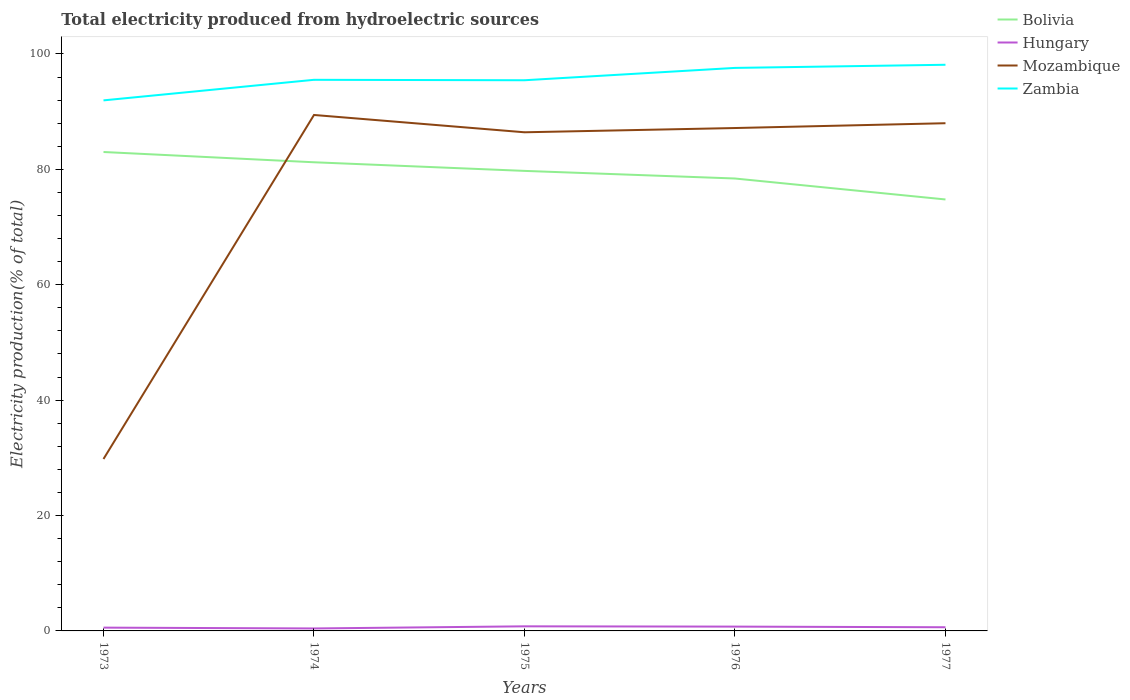How many different coloured lines are there?
Your answer should be compact. 4. Is the number of lines equal to the number of legend labels?
Keep it short and to the point. Yes. Across all years, what is the maximum total electricity produced in Hungary?
Give a very brief answer. 0.43. In which year was the total electricity produced in Bolivia maximum?
Keep it short and to the point. 1977. What is the total total electricity produced in Hungary in the graph?
Keep it short and to the point. 0.15. What is the difference between the highest and the second highest total electricity produced in Mozambique?
Ensure brevity in your answer.  59.63. How many lines are there?
Give a very brief answer. 4. How many years are there in the graph?
Your answer should be compact. 5. Are the values on the major ticks of Y-axis written in scientific E-notation?
Provide a succinct answer. No. Does the graph contain any zero values?
Offer a terse response. No. Does the graph contain grids?
Offer a very short reply. No. Where does the legend appear in the graph?
Ensure brevity in your answer.  Top right. How many legend labels are there?
Provide a succinct answer. 4. What is the title of the graph?
Your response must be concise. Total electricity produced from hydroelectric sources. What is the label or title of the X-axis?
Make the answer very short. Years. What is the label or title of the Y-axis?
Your response must be concise. Electricity production(% of total). What is the Electricity production(% of total) of Bolivia in 1973?
Provide a short and direct response. 83.01. What is the Electricity production(% of total) of Hungary in 1973?
Offer a very short reply. 0.57. What is the Electricity production(% of total) in Mozambique in 1973?
Provide a succinct answer. 29.8. What is the Electricity production(% of total) of Zambia in 1973?
Your answer should be compact. 91.95. What is the Electricity production(% of total) in Bolivia in 1974?
Your response must be concise. 81.23. What is the Electricity production(% of total) in Hungary in 1974?
Offer a terse response. 0.43. What is the Electricity production(% of total) in Mozambique in 1974?
Ensure brevity in your answer.  89.42. What is the Electricity production(% of total) of Zambia in 1974?
Offer a very short reply. 95.52. What is the Electricity production(% of total) in Bolivia in 1975?
Make the answer very short. 79.73. What is the Electricity production(% of total) in Hungary in 1975?
Ensure brevity in your answer.  0.8. What is the Electricity production(% of total) in Mozambique in 1975?
Make the answer very short. 86.42. What is the Electricity production(% of total) of Zambia in 1975?
Give a very brief answer. 95.44. What is the Electricity production(% of total) of Bolivia in 1976?
Provide a succinct answer. 78.41. What is the Electricity production(% of total) of Hungary in 1976?
Offer a very short reply. 0.75. What is the Electricity production(% of total) in Mozambique in 1976?
Keep it short and to the point. 87.16. What is the Electricity production(% of total) in Zambia in 1976?
Your response must be concise. 97.58. What is the Electricity production(% of total) of Bolivia in 1977?
Your answer should be compact. 74.78. What is the Electricity production(% of total) of Hungary in 1977?
Provide a succinct answer. 0.64. What is the Electricity production(% of total) in Mozambique in 1977?
Keep it short and to the point. 87.99. What is the Electricity production(% of total) of Zambia in 1977?
Offer a terse response. 98.13. Across all years, what is the maximum Electricity production(% of total) of Bolivia?
Keep it short and to the point. 83.01. Across all years, what is the maximum Electricity production(% of total) of Hungary?
Provide a succinct answer. 0.8. Across all years, what is the maximum Electricity production(% of total) in Mozambique?
Ensure brevity in your answer.  89.42. Across all years, what is the maximum Electricity production(% of total) of Zambia?
Your answer should be very brief. 98.13. Across all years, what is the minimum Electricity production(% of total) in Bolivia?
Your answer should be very brief. 74.78. Across all years, what is the minimum Electricity production(% of total) in Hungary?
Give a very brief answer. 0.43. Across all years, what is the minimum Electricity production(% of total) in Mozambique?
Your response must be concise. 29.8. Across all years, what is the minimum Electricity production(% of total) of Zambia?
Your response must be concise. 91.95. What is the total Electricity production(% of total) of Bolivia in the graph?
Provide a short and direct response. 397.16. What is the total Electricity production(% of total) in Hungary in the graph?
Keep it short and to the point. 3.18. What is the total Electricity production(% of total) of Mozambique in the graph?
Offer a terse response. 380.8. What is the total Electricity production(% of total) of Zambia in the graph?
Offer a terse response. 478.62. What is the difference between the Electricity production(% of total) of Bolivia in 1973 and that in 1974?
Your answer should be compact. 1.78. What is the difference between the Electricity production(% of total) in Hungary in 1973 and that in 1974?
Your answer should be very brief. 0.15. What is the difference between the Electricity production(% of total) of Mozambique in 1973 and that in 1974?
Give a very brief answer. -59.63. What is the difference between the Electricity production(% of total) of Zambia in 1973 and that in 1974?
Provide a succinct answer. -3.56. What is the difference between the Electricity production(% of total) of Bolivia in 1973 and that in 1975?
Keep it short and to the point. 3.27. What is the difference between the Electricity production(% of total) of Hungary in 1973 and that in 1975?
Ensure brevity in your answer.  -0.22. What is the difference between the Electricity production(% of total) of Mozambique in 1973 and that in 1975?
Make the answer very short. -56.63. What is the difference between the Electricity production(% of total) of Zambia in 1973 and that in 1975?
Ensure brevity in your answer.  -3.49. What is the difference between the Electricity production(% of total) of Bolivia in 1973 and that in 1976?
Offer a terse response. 4.59. What is the difference between the Electricity production(% of total) of Hungary in 1973 and that in 1976?
Your answer should be very brief. -0.18. What is the difference between the Electricity production(% of total) in Mozambique in 1973 and that in 1976?
Provide a succinct answer. -57.36. What is the difference between the Electricity production(% of total) of Zambia in 1973 and that in 1976?
Your answer should be compact. -5.63. What is the difference between the Electricity production(% of total) in Bolivia in 1973 and that in 1977?
Make the answer very short. 8.23. What is the difference between the Electricity production(% of total) of Hungary in 1973 and that in 1977?
Your response must be concise. -0.06. What is the difference between the Electricity production(% of total) of Mozambique in 1973 and that in 1977?
Ensure brevity in your answer.  -58.2. What is the difference between the Electricity production(% of total) of Zambia in 1973 and that in 1977?
Offer a terse response. -6.17. What is the difference between the Electricity production(% of total) in Bolivia in 1974 and that in 1975?
Ensure brevity in your answer.  1.49. What is the difference between the Electricity production(% of total) in Hungary in 1974 and that in 1975?
Your answer should be compact. -0.37. What is the difference between the Electricity production(% of total) in Mozambique in 1974 and that in 1975?
Offer a terse response. 3. What is the difference between the Electricity production(% of total) in Zambia in 1974 and that in 1975?
Ensure brevity in your answer.  0.08. What is the difference between the Electricity production(% of total) in Bolivia in 1974 and that in 1976?
Ensure brevity in your answer.  2.81. What is the difference between the Electricity production(% of total) in Hungary in 1974 and that in 1976?
Give a very brief answer. -0.32. What is the difference between the Electricity production(% of total) in Mozambique in 1974 and that in 1976?
Keep it short and to the point. 2.26. What is the difference between the Electricity production(% of total) in Zambia in 1974 and that in 1976?
Your answer should be very brief. -2.06. What is the difference between the Electricity production(% of total) in Bolivia in 1974 and that in 1977?
Offer a terse response. 6.45. What is the difference between the Electricity production(% of total) in Hungary in 1974 and that in 1977?
Ensure brevity in your answer.  -0.21. What is the difference between the Electricity production(% of total) of Mozambique in 1974 and that in 1977?
Keep it short and to the point. 1.43. What is the difference between the Electricity production(% of total) in Zambia in 1974 and that in 1977?
Offer a very short reply. -2.61. What is the difference between the Electricity production(% of total) of Bolivia in 1975 and that in 1976?
Make the answer very short. 1.32. What is the difference between the Electricity production(% of total) of Hungary in 1975 and that in 1976?
Your response must be concise. 0.05. What is the difference between the Electricity production(% of total) of Mozambique in 1975 and that in 1976?
Provide a short and direct response. -0.74. What is the difference between the Electricity production(% of total) in Zambia in 1975 and that in 1976?
Give a very brief answer. -2.14. What is the difference between the Electricity production(% of total) in Bolivia in 1975 and that in 1977?
Give a very brief answer. 4.95. What is the difference between the Electricity production(% of total) in Hungary in 1975 and that in 1977?
Make the answer very short. 0.16. What is the difference between the Electricity production(% of total) of Mozambique in 1975 and that in 1977?
Your answer should be very brief. -1.57. What is the difference between the Electricity production(% of total) in Zambia in 1975 and that in 1977?
Your answer should be compact. -2.68. What is the difference between the Electricity production(% of total) of Bolivia in 1976 and that in 1977?
Offer a terse response. 3.63. What is the difference between the Electricity production(% of total) of Hungary in 1976 and that in 1977?
Make the answer very short. 0.11. What is the difference between the Electricity production(% of total) in Mozambique in 1976 and that in 1977?
Keep it short and to the point. -0.83. What is the difference between the Electricity production(% of total) of Zambia in 1976 and that in 1977?
Offer a very short reply. -0.55. What is the difference between the Electricity production(% of total) in Bolivia in 1973 and the Electricity production(% of total) in Hungary in 1974?
Your answer should be compact. 82.58. What is the difference between the Electricity production(% of total) in Bolivia in 1973 and the Electricity production(% of total) in Mozambique in 1974?
Provide a succinct answer. -6.42. What is the difference between the Electricity production(% of total) of Bolivia in 1973 and the Electricity production(% of total) of Zambia in 1974?
Offer a very short reply. -12.51. What is the difference between the Electricity production(% of total) in Hungary in 1973 and the Electricity production(% of total) in Mozambique in 1974?
Your answer should be very brief. -88.85. What is the difference between the Electricity production(% of total) in Hungary in 1973 and the Electricity production(% of total) in Zambia in 1974?
Your answer should be very brief. -94.95. What is the difference between the Electricity production(% of total) in Mozambique in 1973 and the Electricity production(% of total) in Zambia in 1974?
Your response must be concise. -65.72. What is the difference between the Electricity production(% of total) in Bolivia in 1973 and the Electricity production(% of total) in Hungary in 1975?
Offer a very short reply. 82.21. What is the difference between the Electricity production(% of total) in Bolivia in 1973 and the Electricity production(% of total) in Mozambique in 1975?
Keep it short and to the point. -3.42. What is the difference between the Electricity production(% of total) of Bolivia in 1973 and the Electricity production(% of total) of Zambia in 1975?
Keep it short and to the point. -12.44. What is the difference between the Electricity production(% of total) in Hungary in 1973 and the Electricity production(% of total) in Mozambique in 1975?
Make the answer very short. -85.85. What is the difference between the Electricity production(% of total) in Hungary in 1973 and the Electricity production(% of total) in Zambia in 1975?
Offer a terse response. -94.87. What is the difference between the Electricity production(% of total) of Mozambique in 1973 and the Electricity production(% of total) of Zambia in 1975?
Provide a short and direct response. -65.64. What is the difference between the Electricity production(% of total) of Bolivia in 1973 and the Electricity production(% of total) of Hungary in 1976?
Your answer should be compact. 82.26. What is the difference between the Electricity production(% of total) in Bolivia in 1973 and the Electricity production(% of total) in Mozambique in 1976?
Make the answer very short. -4.16. What is the difference between the Electricity production(% of total) of Bolivia in 1973 and the Electricity production(% of total) of Zambia in 1976?
Give a very brief answer. -14.57. What is the difference between the Electricity production(% of total) in Hungary in 1973 and the Electricity production(% of total) in Mozambique in 1976?
Offer a very short reply. -86.59. What is the difference between the Electricity production(% of total) of Hungary in 1973 and the Electricity production(% of total) of Zambia in 1976?
Offer a very short reply. -97.01. What is the difference between the Electricity production(% of total) in Mozambique in 1973 and the Electricity production(% of total) in Zambia in 1976?
Offer a terse response. -67.78. What is the difference between the Electricity production(% of total) of Bolivia in 1973 and the Electricity production(% of total) of Hungary in 1977?
Your answer should be compact. 82.37. What is the difference between the Electricity production(% of total) of Bolivia in 1973 and the Electricity production(% of total) of Mozambique in 1977?
Keep it short and to the point. -4.99. What is the difference between the Electricity production(% of total) in Bolivia in 1973 and the Electricity production(% of total) in Zambia in 1977?
Offer a terse response. -15.12. What is the difference between the Electricity production(% of total) in Hungary in 1973 and the Electricity production(% of total) in Mozambique in 1977?
Your response must be concise. -87.42. What is the difference between the Electricity production(% of total) in Hungary in 1973 and the Electricity production(% of total) in Zambia in 1977?
Keep it short and to the point. -97.55. What is the difference between the Electricity production(% of total) of Mozambique in 1973 and the Electricity production(% of total) of Zambia in 1977?
Provide a short and direct response. -68.33. What is the difference between the Electricity production(% of total) in Bolivia in 1974 and the Electricity production(% of total) in Hungary in 1975?
Provide a short and direct response. 80.43. What is the difference between the Electricity production(% of total) in Bolivia in 1974 and the Electricity production(% of total) in Mozambique in 1975?
Provide a short and direct response. -5.2. What is the difference between the Electricity production(% of total) in Bolivia in 1974 and the Electricity production(% of total) in Zambia in 1975?
Your answer should be very brief. -14.22. What is the difference between the Electricity production(% of total) in Hungary in 1974 and the Electricity production(% of total) in Mozambique in 1975?
Give a very brief answer. -86. What is the difference between the Electricity production(% of total) in Hungary in 1974 and the Electricity production(% of total) in Zambia in 1975?
Make the answer very short. -95.02. What is the difference between the Electricity production(% of total) in Mozambique in 1974 and the Electricity production(% of total) in Zambia in 1975?
Offer a very short reply. -6.02. What is the difference between the Electricity production(% of total) in Bolivia in 1974 and the Electricity production(% of total) in Hungary in 1976?
Make the answer very short. 80.48. What is the difference between the Electricity production(% of total) of Bolivia in 1974 and the Electricity production(% of total) of Mozambique in 1976?
Provide a short and direct response. -5.94. What is the difference between the Electricity production(% of total) of Bolivia in 1974 and the Electricity production(% of total) of Zambia in 1976?
Give a very brief answer. -16.36. What is the difference between the Electricity production(% of total) of Hungary in 1974 and the Electricity production(% of total) of Mozambique in 1976?
Provide a succinct answer. -86.73. What is the difference between the Electricity production(% of total) in Hungary in 1974 and the Electricity production(% of total) in Zambia in 1976?
Your answer should be compact. -97.15. What is the difference between the Electricity production(% of total) in Mozambique in 1974 and the Electricity production(% of total) in Zambia in 1976?
Make the answer very short. -8.16. What is the difference between the Electricity production(% of total) in Bolivia in 1974 and the Electricity production(% of total) in Hungary in 1977?
Offer a very short reply. 80.59. What is the difference between the Electricity production(% of total) in Bolivia in 1974 and the Electricity production(% of total) in Mozambique in 1977?
Your answer should be very brief. -6.77. What is the difference between the Electricity production(% of total) of Bolivia in 1974 and the Electricity production(% of total) of Zambia in 1977?
Give a very brief answer. -16.9. What is the difference between the Electricity production(% of total) of Hungary in 1974 and the Electricity production(% of total) of Mozambique in 1977?
Ensure brevity in your answer.  -87.57. What is the difference between the Electricity production(% of total) of Hungary in 1974 and the Electricity production(% of total) of Zambia in 1977?
Keep it short and to the point. -97.7. What is the difference between the Electricity production(% of total) in Mozambique in 1974 and the Electricity production(% of total) in Zambia in 1977?
Keep it short and to the point. -8.7. What is the difference between the Electricity production(% of total) of Bolivia in 1975 and the Electricity production(% of total) of Hungary in 1976?
Your answer should be compact. 78.98. What is the difference between the Electricity production(% of total) of Bolivia in 1975 and the Electricity production(% of total) of Mozambique in 1976?
Your answer should be compact. -7.43. What is the difference between the Electricity production(% of total) of Bolivia in 1975 and the Electricity production(% of total) of Zambia in 1976?
Offer a very short reply. -17.85. What is the difference between the Electricity production(% of total) in Hungary in 1975 and the Electricity production(% of total) in Mozambique in 1976?
Your response must be concise. -86.36. What is the difference between the Electricity production(% of total) of Hungary in 1975 and the Electricity production(% of total) of Zambia in 1976?
Offer a very short reply. -96.78. What is the difference between the Electricity production(% of total) in Mozambique in 1975 and the Electricity production(% of total) in Zambia in 1976?
Your answer should be compact. -11.16. What is the difference between the Electricity production(% of total) in Bolivia in 1975 and the Electricity production(% of total) in Hungary in 1977?
Ensure brevity in your answer.  79.1. What is the difference between the Electricity production(% of total) of Bolivia in 1975 and the Electricity production(% of total) of Mozambique in 1977?
Give a very brief answer. -8.26. What is the difference between the Electricity production(% of total) of Bolivia in 1975 and the Electricity production(% of total) of Zambia in 1977?
Provide a short and direct response. -18.39. What is the difference between the Electricity production(% of total) of Hungary in 1975 and the Electricity production(% of total) of Mozambique in 1977?
Give a very brief answer. -87.2. What is the difference between the Electricity production(% of total) of Hungary in 1975 and the Electricity production(% of total) of Zambia in 1977?
Provide a short and direct response. -97.33. What is the difference between the Electricity production(% of total) in Mozambique in 1975 and the Electricity production(% of total) in Zambia in 1977?
Keep it short and to the point. -11.7. What is the difference between the Electricity production(% of total) of Bolivia in 1976 and the Electricity production(% of total) of Hungary in 1977?
Provide a short and direct response. 77.78. What is the difference between the Electricity production(% of total) of Bolivia in 1976 and the Electricity production(% of total) of Mozambique in 1977?
Your answer should be very brief. -9.58. What is the difference between the Electricity production(% of total) in Bolivia in 1976 and the Electricity production(% of total) in Zambia in 1977?
Your response must be concise. -19.71. What is the difference between the Electricity production(% of total) of Hungary in 1976 and the Electricity production(% of total) of Mozambique in 1977?
Your answer should be very brief. -87.25. What is the difference between the Electricity production(% of total) in Hungary in 1976 and the Electricity production(% of total) in Zambia in 1977?
Make the answer very short. -97.38. What is the difference between the Electricity production(% of total) of Mozambique in 1976 and the Electricity production(% of total) of Zambia in 1977?
Give a very brief answer. -10.96. What is the average Electricity production(% of total) of Bolivia per year?
Your response must be concise. 79.43. What is the average Electricity production(% of total) in Hungary per year?
Give a very brief answer. 0.64. What is the average Electricity production(% of total) in Mozambique per year?
Your answer should be very brief. 76.16. What is the average Electricity production(% of total) of Zambia per year?
Provide a short and direct response. 95.72. In the year 1973, what is the difference between the Electricity production(% of total) of Bolivia and Electricity production(% of total) of Hungary?
Your answer should be very brief. 82.43. In the year 1973, what is the difference between the Electricity production(% of total) of Bolivia and Electricity production(% of total) of Mozambique?
Keep it short and to the point. 53.21. In the year 1973, what is the difference between the Electricity production(% of total) in Bolivia and Electricity production(% of total) in Zambia?
Provide a succinct answer. -8.95. In the year 1973, what is the difference between the Electricity production(% of total) in Hungary and Electricity production(% of total) in Mozambique?
Your response must be concise. -29.22. In the year 1973, what is the difference between the Electricity production(% of total) in Hungary and Electricity production(% of total) in Zambia?
Keep it short and to the point. -91.38. In the year 1973, what is the difference between the Electricity production(% of total) in Mozambique and Electricity production(% of total) in Zambia?
Offer a terse response. -62.16. In the year 1974, what is the difference between the Electricity production(% of total) of Bolivia and Electricity production(% of total) of Hungary?
Your answer should be very brief. 80.8. In the year 1974, what is the difference between the Electricity production(% of total) of Bolivia and Electricity production(% of total) of Mozambique?
Give a very brief answer. -8.2. In the year 1974, what is the difference between the Electricity production(% of total) in Bolivia and Electricity production(% of total) in Zambia?
Keep it short and to the point. -14.29. In the year 1974, what is the difference between the Electricity production(% of total) in Hungary and Electricity production(% of total) in Mozambique?
Make the answer very short. -89. In the year 1974, what is the difference between the Electricity production(% of total) in Hungary and Electricity production(% of total) in Zambia?
Provide a succinct answer. -95.09. In the year 1974, what is the difference between the Electricity production(% of total) of Mozambique and Electricity production(% of total) of Zambia?
Offer a very short reply. -6.09. In the year 1975, what is the difference between the Electricity production(% of total) of Bolivia and Electricity production(% of total) of Hungary?
Keep it short and to the point. 78.94. In the year 1975, what is the difference between the Electricity production(% of total) in Bolivia and Electricity production(% of total) in Mozambique?
Ensure brevity in your answer.  -6.69. In the year 1975, what is the difference between the Electricity production(% of total) of Bolivia and Electricity production(% of total) of Zambia?
Your answer should be very brief. -15.71. In the year 1975, what is the difference between the Electricity production(% of total) of Hungary and Electricity production(% of total) of Mozambique?
Make the answer very short. -85.63. In the year 1975, what is the difference between the Electricity production(% of total) of Hungary and Electricity production(% of total) of Zambia?
Keep it short and to the point. -94.65. In the year 1975, what is the difference between the Electricity production(% of total) in Mozambique and Electricity production(% of total) in Zambia?
Offer a terse response. -9.02. In the year 1976, what is the difference between the Electricity production(% of total) of Bolivia and Electricity production(% of total) of Hungary?
Your answer should be very brief. 77.66. In the year 1976, what is the difference between the Electricity production(% of total) in Bolivia and Electricity production(% of total) in Mozambique?
Offer a very short reply. -8.75. In the year 1976, what is the difference between the Electricity production(% of total) in Bolivia and Electricity production(% of total) in Zambia?
Your answer should be compact. -19.17. In the year 1976, what is the difference between the Electricity production(% of total) in Hungary and Electricity production(% of total) in Mozambique?
Keep it short and to the point. -86.41. In the year 1976, what is the difference between the Electricity production(% of total) in Hungary and Electricity production(% of total) in Zambia?
Make the answer very short. -96.83. In the year 1976, what is the difference between the Electricity production(% of total) of Mozambique and Electricity production(% of total) of Zambia?
Offer a very short reply. -10.42. In the year 1977, what is the difference between the Electricity production(% of total) in Bolivia and Electricity production(% of total) in Hungary?
Your answer should be very brief. 74.14. In the year 1977, what is the difference between the Electricity production(% of total) of Bolivia and Electricity production(% of total) of Mozambique?
Make the answer very short. -13.21. In the year 1977, what is the difference between the Electricity production(% of total) in Bolivia and Electricity production(% of total) in Zambia?
Your answer should be very brief. -23.35. In the year 1977, what is the difference between the Electricity production(% of total) in Hungary and Electricity production(% of total) in Mozambique?
Your answer should be very brief. -87.36. In the year 1977, what is the difference between the Electricity production(% of total) of Hungary and Electricity production(% of total) of Zambia?
Your answer should be very brief. -97.49. In the year 1977, what is the difference between the Electricity production(% of total) in Mozambique and Electricity production(% of total) in Zambia?
Keep it short and to the point. -10.13. What is the ratio of the Electricity production(% of total) in Bolivia in 1973 to that in 1974?
Make the answer very short. 1.02. What is the ratio of the Electricity production(% of total) of Hungary in 1973 to that in 1974?
Your answer should be compact. 1.34. What is the ratio of the Electricity production(% of total) in Mozambique in 1973 to that in 1974?
Ensure brevity in your answer.  0.33. What is the ratio of the Electricity production(% of total) in Zambia in 1973 to that in 1974?
Your answer should be very brief. 0.96. What is the ratio of the Electricity production(% of total) in Bolivia in 1973 to that in 1975?
Offer a terse response. 1.04. What is the ratio of the Electricity production(% of total) in Hungary in 1973 to that in 1975?
Your response must be concise. 0.72. What is the ratio of the Electricity production(% of total) of Mozambique in 1973 to that in 1975?
Your answer should be very brief. 0.34. What is the ratio of the Electricity production(% of total) in Zambia in 1973 to that in 1975?
Provide a short and direct response. 0.96. What is the ratio of the Electricity production(% of total) in Bolivia in 1973 to that in 1976?
Keep it short and to the point. 1.06. What is the ratio of the Electricity production(% of total) in Hungary in 1973 to that in 1976?
Your response must be concise. 0.77. What is the ratio of the Electricity production(% of total) of Mozambique in 1973 to that in 1976?
Ensure brevity in your answer.  0.34. What is the ratio of the Electricity production(% of total) in Zambia in 1973 to that in 1976?
Your response must be concise. 0.94. What is the ratio of the Electricity production(% of total) of Bolivia in 1973 to that in 1977?
Offer a terse response. 1.11. What is the ratio of the Electricity production(% of total) in Hungary in 1973 to that in 1977?
Your answer should be compact. 0.9. What is the ratio of the Electricity production(% of total) in Mozambique in 1973 to that in 1977?
Your answer should be compact. 0.34. What is the ratio of the Electricity production(% of total) in Zambia in 1973 to that in 1977?
Provide a short and direct response. 0.94. What is the ratio of the Electricity production(% of total) of Bolivia in 1974 to that in 1975?
Offer a terse response. 1.02. What is the ratio of the Electricity production(% of total) in Hungary in 1974 to that in 1975?
Keep it short and to the point. 0.54. What is the ratio of the Electricity production(% of total) in Mozambique in 1974 to that in 1975?
Give a very brief answer. 1.03. What is the ratio of the Electricity production(% of total) of Bolivia in 1974 to that in 1976?
Your response must be concise. 1.04. What is the ratio of the Electricity production(% of total) in Hungary in 1974 to that in 1976?
Provide a succinct answer. 0.57. What is the ratio of the Electricity production(% of total) in Mozambique in 1974 to that in 1976?
Your response must be concise. 1.03. What is the ratio of the Electricity production(% of total) in Zambia in 1974 to that in 1976?
Make the answer very short. 0.98. What is the ratio of the Electricity production(% of total) of Bolivia in 1974 to that in 1977?
Make the answer very short. 1.09. What is the ratio of the Electricity production(% of total) in Hungary in 1974 to that in 1977?
Offer a terse response. 0.67. What is the ratio of the Electricity production(% of total) in Mozambique in 1974 to that in 1977?
Your answer should be very brief. 1.02. What is the ratio of the Electricity production(% of total) in Zambia in 1974 to that in 1977?
Keep it short and to the point. 0.97. What is the ratio of the Electricity production(% of total) in Bolivia in 1975 to that in 1976?
Provide a short and direct response. 1.02. What is the ratio of the Electricity production(% of total) of Hungary in 1975 to that in 1976?
Your response must be concise. 1.06. What is the ratio of the Electricity production(% of total) of Zambia in 1975 to that in 1976?
Keep it short and to the point. 0.98. What is the ratio of the Electricity production(% of total) of Bolivia in 1975 to that in 1977?
Give a very brief answer. 1.07. What is the ratio of the Electricity production(% of total) of Hungary in 1975 to that in 1977?
Provide a succinct answer. 1.25. What is the ratio of the Electricity production(% of total) of Mozambique in 1975 to that in 1977?
Offer a very short reply. 0.98. What is the ratio of the Electricity production(% of total) of Zambia in 1975 to that in 1977?
Make the answer very short. 0.97. What is the ratio of the Electricity production(% of total) in Bolivia in 1976 to that in 1977?
Your answer should be compact. 1.05. What is the ratio of the Electricity production(% of total) in Hungary in 1976 to that in 1977?
Give a very brief answer. 1.18. What is the difference between the highest and the second highest Electricity production(% of total) of Bolivia?
Offer a terse response. 1.78. What is the difference between the highest and the second highest Electricity production(% of total) in Hungary?
Provide a succinct answer. 0.05. What is the difference between the highest and the second highest Electricity production(% of total) in Mozambique?
Provide a succinct answer. 1.43. What is the difference between the highest and the second highest Electricity production(% of total) in Zambia?
Your answer should be very brief. 0.55. What is the difference between the highest and the lowest Electricity production(% of total) in Bolivia?
Offer a very short reply. 8.23. What is the difference between the highest and the lowest Electricity production(% of total) of Hungary?
Offer a terse response. 0.37. What is the difference between the highest and the lowest Electricity production(% of total) of Mozambique?
Provide a short and direct response. 59.63. What is the difference between the highest and the lowest Electricity production(% of total) of Zambia?
Ensure brevity in your answer.  6.17. 